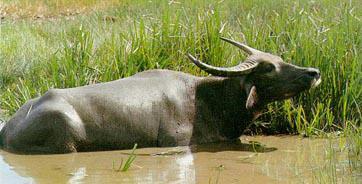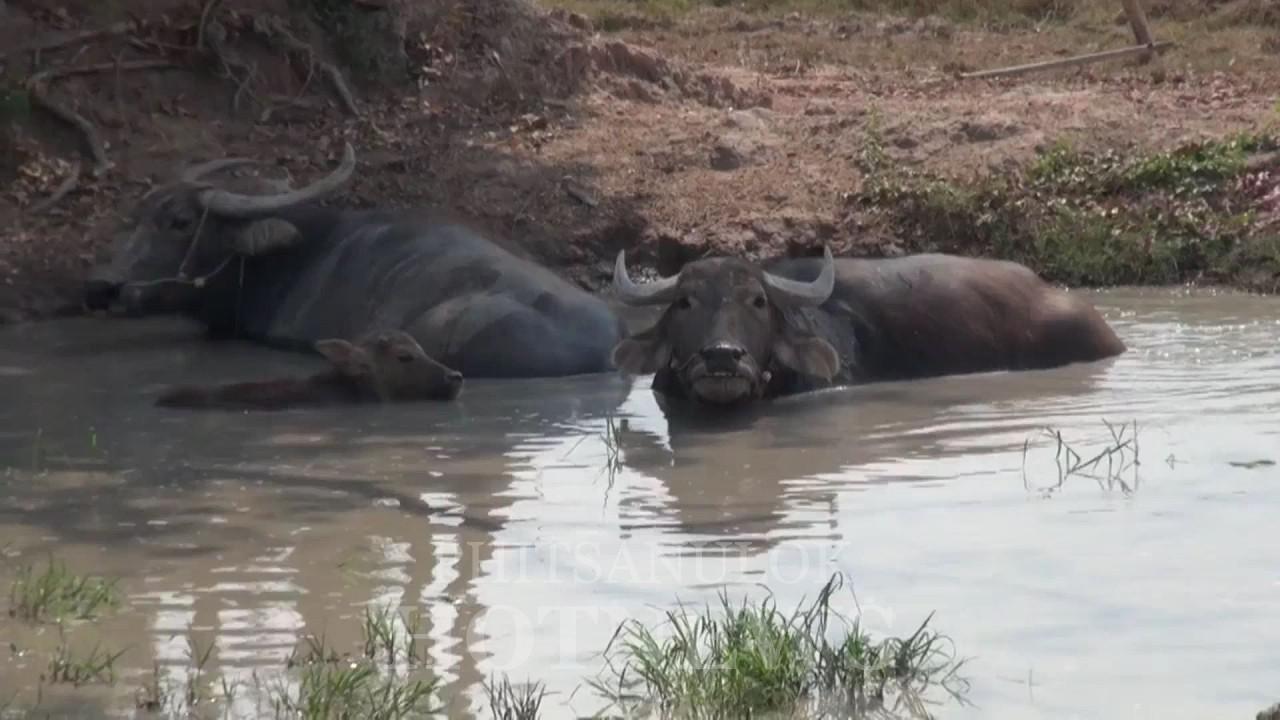The first image is the image on the left, the second image is the image on the right. Examine the images to the left and right. Is the description "An image shows exactly one water buffalo in a muddy pit, with its head turned forward." accurate? Answer yes or no. No. The first image is the image on the left, the second image is the image on the right. Analyze the images presented: Is the assertion "There are at least four adult buffalos having a mud bath." valid? Answer yes or no. No. 